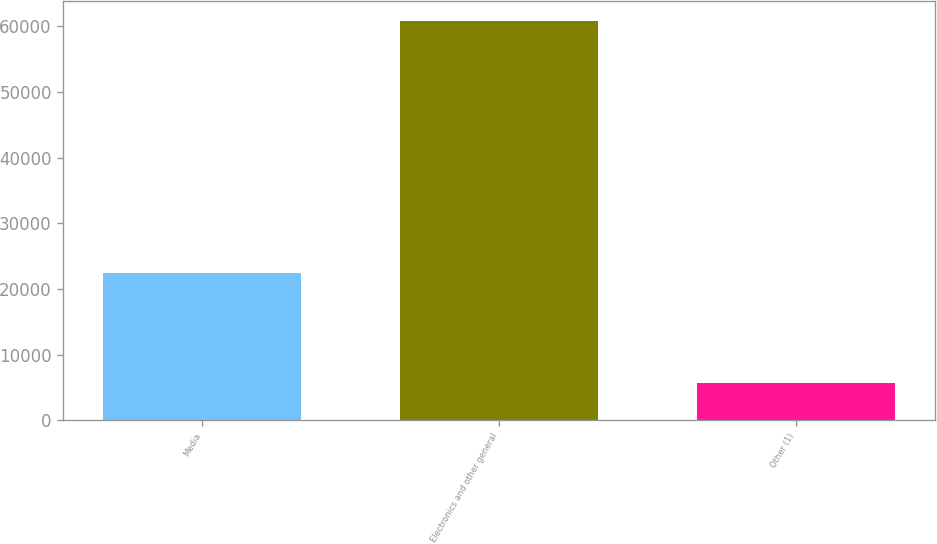Convert chart to OTSL. <chart><loc_0><loc_0><loc_500><loc_500><bar_chart><fcel>Media<fcel>Electronics and other general<fcel>Other (1)<nl><fcel>22505<fcel>60886<fcel>5597<nl></chart> 